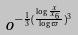<formula> <loc_0><loc_0><loc_500><loc_500>o ^ { - \frac { 1 } { 3 } ( \frac { \log \frac { x } { x _ { 6 } } } { \log \varpi } ) ^ { 3 } }</formula> 